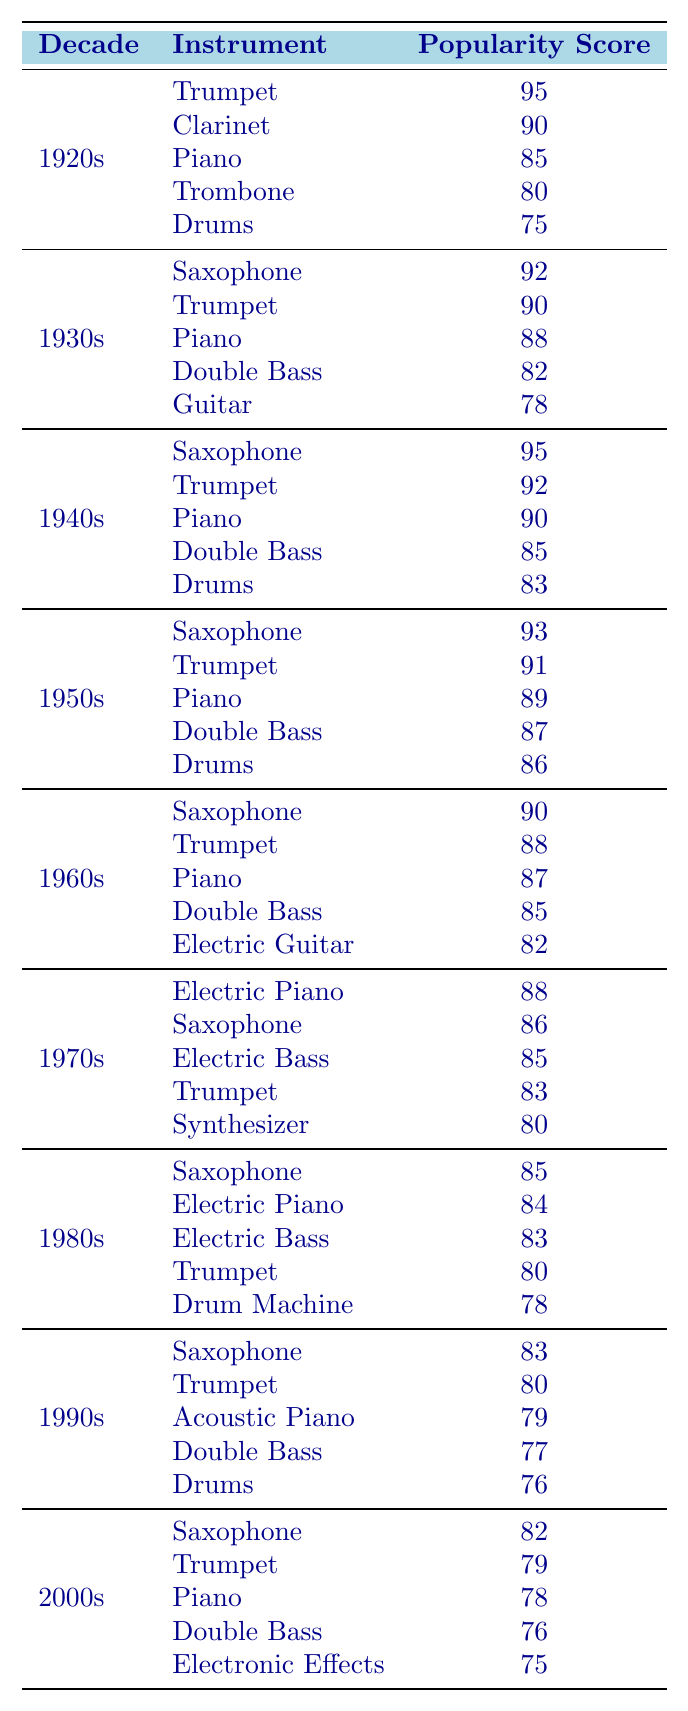What instrument had the highest popularity score in the 1940s? Looking at the data for the 1940s, the highest popularity score is 95, which corresponds to the Saxophone.
Answer: Saxophone Which decade saw a decline in Trumpet's popularity from the previous decade? Comparing the popularity scores, the Trumpet had a score of 92 in the 1940s and dropped to 91 in the 1950s, indicating a decline.
Answer: Yes What is the average popularity score of the Saxophone across all decades? The popularity scores for Saxophone are: 92 (1930s), 95 (1940s), 93 (1950s), 90 (1960s), 86 (1970s), 85 (1980s), 83 (1990s), 82 (2000s). The total is 89.5. Therefore, the average is 89.5 / 8 = 89.5.
Answer: 89.5 How many instruments had a popularity score of over 85 in the 1950s? The instruments from the 1950s with scores above 85 are: Saxophone (93), Trumpet (91), Piano (89), Double Bass (87), and Drums (86), totaling 5 instruments.
Answer: 5 In which decade did the Electric Guitar first appear, and what was its popularity score? The Electric Guitar first appears in the 1960s with a popularity score of 82 according to the data.
Answer: 1960s, 82 What instrument's popularity score decreased the most from the 1970s to the 1980s? The Electric Piano scored 88 in the 1970s and dropped to 84 in the 1980s, showing a decrease of 4 points, which is the highest decrease among instruments.
Answer: Electric Piano Was the popularity of Drums consistently above 75 across all decades? Tracking the Drums across the decades: 75 (1920s), 83 (1940s), 86 (1950s), 76 (1990s), and 76 (2000s). The score dropped below 75 in the 2000s, showing inconsistency.
Answer: No Which instrument became the most popular overall by the end of the 1950s? By the end of the 1950s, the Saxophone maintained one of the highest scores at 93, with the second highest being Trumpet at 91. Saxophone can be seen as the most popular.
Answer: Saxophone 